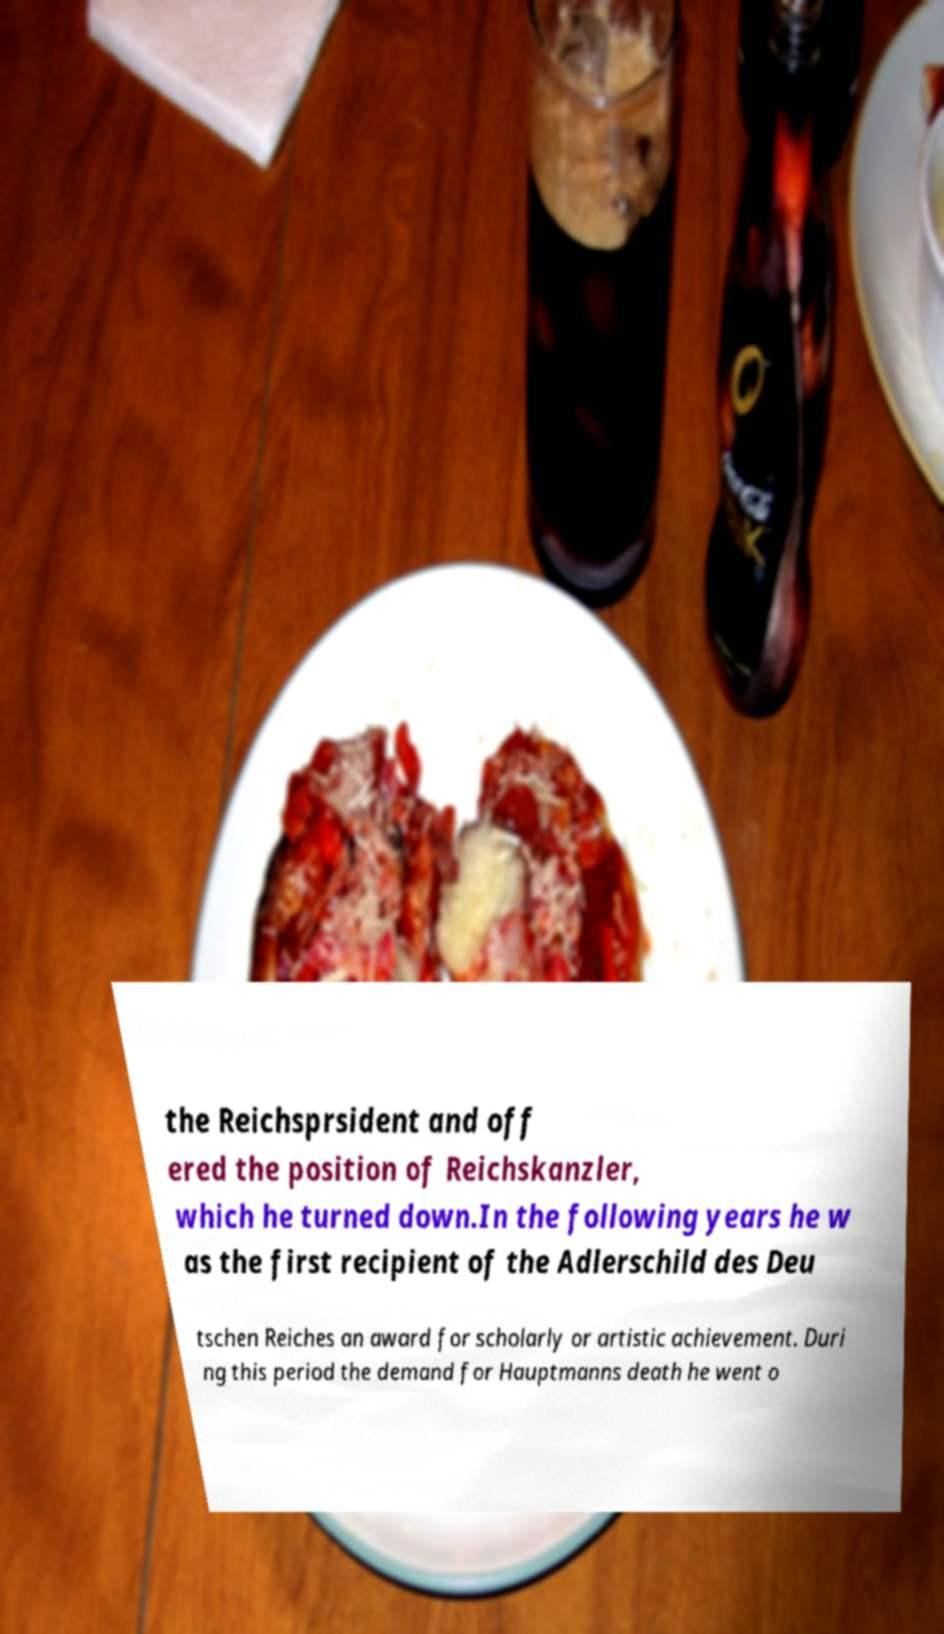Can you accurately transcribe the text from the provided image for me? the Reichsprsident and off ered the position of Reichskanzler, which he turned down.In the following years he w as the first recipient of the Adlerschild des Deu tschen Reiches an award for scholarly or artistic achievement. Duri ng this period the demand for Hauptmanns death he went o 